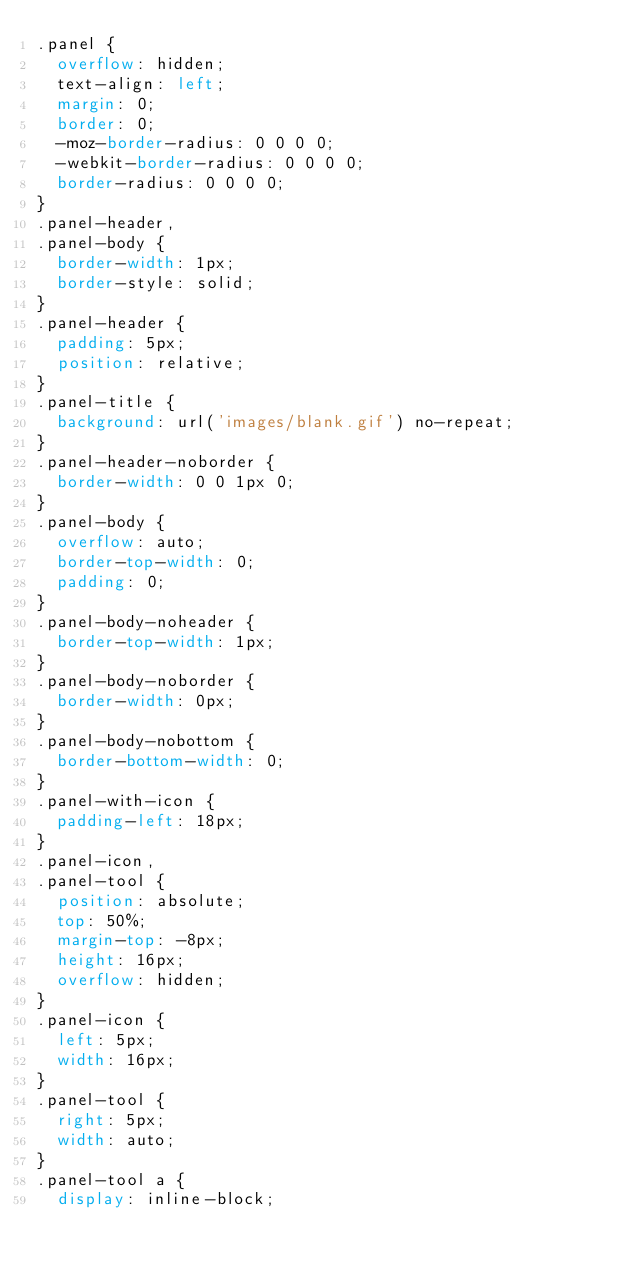Convert code to text. <code><loc_0><loc_0><loc_500><loc_500><_CSS_>.panel {
  overflow: hidden;
  text-align: left;
  margin: 0;
  border: 0;
  -moz-border-radius: 0 0 0 0;
  -webkit-border-radius: 0 0 0 0;
  border-radius: 0 0 0 0;
}
.panel-header,
.panel-body {
  border-width: 1px;
  border-style: solid;
}
.panel-header {
  padding: 5px;
  position: relative;
}
.panel-title {
  background: url('images/blank.gif') no-repeat;
}
.panel-header-noborder {
  border-width: 0 0 1px 0;
}
.panel-body {
  overflow: auto;
  border-top-width: 0;
  padding: 0;
}
.panel-body-noheader {
  border-top-width: 1px;
}
.panel-body-noborder {
  border-width: 0px;
}
.panel-body-nobottom {
  border-bottom-width: 0;
}
.panel-with-icon {
  padding-left: 18px;
}
.panel-icon,
.panel-tool {
  position: absolute;
  top: 50%;
  margin-top: -8px;
  height: 16px;
  overflow: hidden;
}
.panel-icon {
  left: 5px;
  width: 16px;
}
.panel-tool {
  right: 5px;
  width: auto;
}
.panel-tool a {
  display: inline-block;</code> 